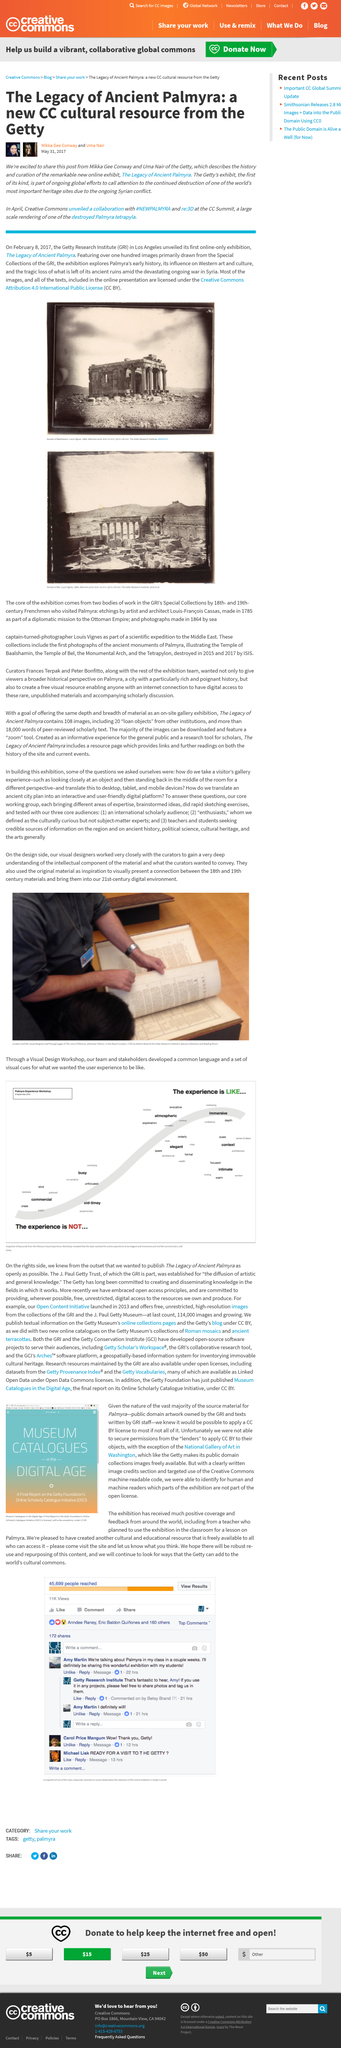Identify some key points in this picture. It is declared that two individuals, namely Mikka Gee Conway and Uma Nair, wrote the article titled 'The Legacy of Ancient Palmyra'. The Getty is exhibiting "The Legacy of Palmyra" online exhibit. At the CC Summit, Creative Commons unveiled a collaboration with #NEWPALMYRA and re:3D. 